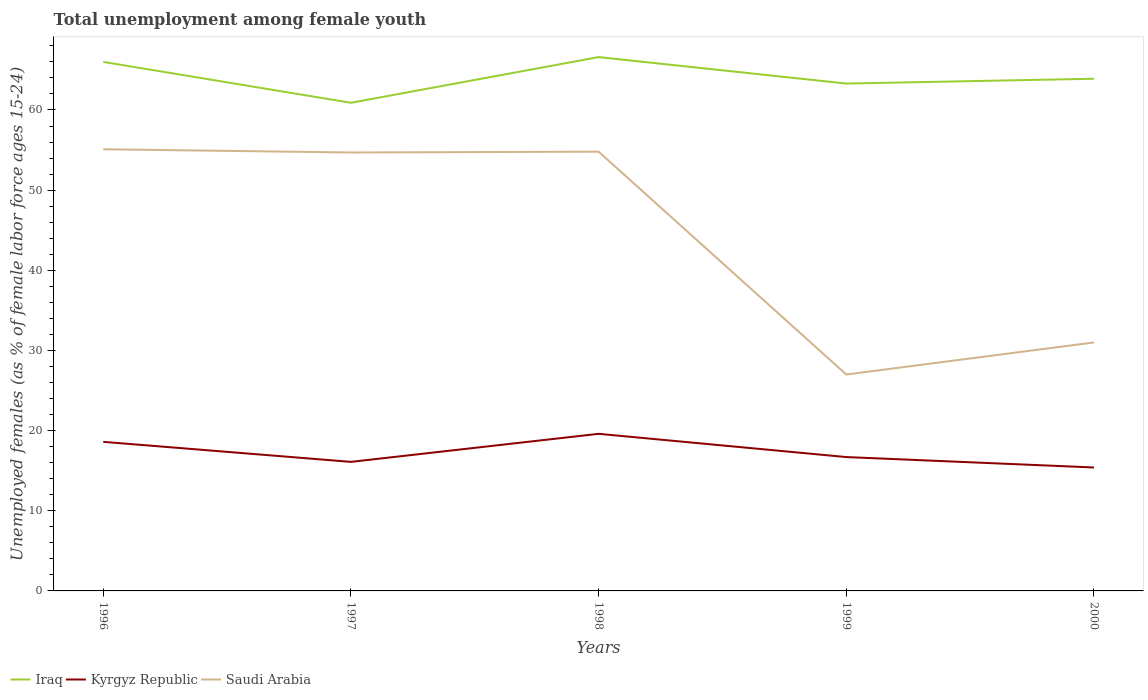How many different coloured lines are there?
Keep it short and to the point. 3. Is the number of lines equal to the number of legend labels?
Keep it short and to the point. Yes. Across all years, what is the maximum percentage of unemployed females in in Kyrgyz Republic?
Your answer should be very brief. 15.4. What is the total percentage of unemployed females in in Kyrgyz Republic in the graph?
Offer a very short reply. -1. What is the difference between the highest and the second highest percentage of unemployed females in in Kyrgyz Republic?
Ensure brevity in your answer.  4.2. What is the difference between the highest and the lowest percentage of unemployed females in in Kyrgyz Republic?
Make the answer very short. 2. Does the graph contain any zero values?
Give a very brief answer. No. Does the graph contain grids?
Make the answer very short. No. Where does the legend appear in the graph?
Offer a terse response. Bottom left. How are the legend labels stacked?
Offer a terse response. Horizontal. What is the title of the graph?
Your answer should be very brief. Total unemployment among female youth. Does "High income: nonOECD" appear as one of the legend labels in the graph?
Make the answer very short. No. What is the label or title of the Y-axis?
Provide a short and direct response. Unemployed females (as % of female labor force ages 15-24). What is the Unemployed females (as % of female labor force ages 15-24) in Kyrgyz Republic in 1996?
Keep it short and to the point. 18.6. What is the Unemployed females (as % of female labor force ages 15-24) of Saudi Arabia in 1996?
Offer a very short reply. 55.1. What is the Unemployed females (as % of female labor force ages 15-24) in Iraq in 1997?
Offer a terse response. 60.9. What is the Unemployed females (as % of female labor force ages 15-24) of Kyrgyz Republic in 1997?
Your answer should be compact. 16.1. What is the Unemployed females (as % of female labor force ages 15-24) in Saudi Arabia in 1997?
Keep it short and to the point. 54.7. What is the Unemployed females (as % of female labor force ages 15-24) in Iraq in 1998?
Your answer should be compact. 66.6. What is the Unemployed females (as % of female labor force ages 15-24) of Kyrgyz Republic in 1998?
Make the answer very short. 19.6. What is the Unemployed females (as % of female labor force ages 15-24) in Saudi Arabia in 1998?
Your answer should be compact. 54.8. What is the Unemployed females (as % of female labor force ages 15-24) of Iraq in 1999?
Offer a terse response. 63.3. What is the Unemployed females (as % of female labor force ages 15-24) of Kyrgyz Republic in 1999?
Provide a short and direct response. 16.7. What is the Unemployed females (as % of female labor force ages 15-24) of Iraq in 2000?
Your answer should be compact. 63.9. What is the Unemployed females (as % of female labor force ages 15-24) in Kyrgyz Republic in 2000?
Offer a terse response. 15.4. What is the Unemployed females (as % of female labor force ages 15-24) in Saudi Arabia in 2000?
Ensure brevity in your answer.  31. Across all years, what is the maximum Unemployed females (as % of female labor force ages 15-24) of Iraq?
Give a very brief answer. 66.6. Across all years, what is the maximum Unemployed females (as % of female labor force ages 15-24) in Kyrgyz Republic?
Offer a very short reply. 19.6. Across all years, what is the maximum Unemployed females (as % of female labor force ages 15-24) in Saudi Arabia?
Make the answer very short. 55.1. Across all years, what is the minimum Unemployed females (as % of female labor force ages 15-24) in Iraq?
Ensure brevity in your answer.  60.9. Across all years, what is the minimum Unemployed females (as % of female labor force ages 15-24) of Kyrgyz Republic?
Provide a short and direct response. 15.4. What is the total Unemployed females (as % of female labor force ages 15-24) of Iraq in the graph?
Your response must be concise. 320.7. What is the total Unemployed females (as % of female labor force ages 15-24) of Kyrgyz Republic in the graph?
Make the answer very short. 86.4. What is the total Unemployed females (as % of female labor force ages 15-24) in Saudi Arabia in the graph?
Offer a terse response. 222.6. What is the difference between the Unemployed females (as % of female labor force ages 15-24) of Iraq in 1996 and that in 1997?
Ensure brevity in your answer.  5.1. What is the difference between the Unemployed females (as % of female labor force ages 15-24) of Kyrgyz Republic in 1996 and that in 1997?
Give a very brief answer. 2.5. What is the difference between the Unemployed females (as % of female labor force ages 15-24) in Iraq in 1996 and that in 1998?
Provide a short and direct response. -0.6. What is the difference between the Unemployed females (as % of female labor force ages 15-24) in Iraq in 1996 and that in 1999?
Your answer should be compact. 2.7. What is the difference between the Unemployed females (as % of female labor force ages 15-24) in Kyrgyz Republic in 1996 and that in 1999?
Provide a short and direct response. 1.9. What is the difference between the Unemployed females (as % of female labor force ages 15-24) of Saudi Arabia in 1996 and that in 1999?
Give a very brief answer. 28.1. What is the difference between the Unemployed females (as % of female labor force ages 15-24) in Iraq in 1996 and that in 2000?
Keep it short and to the point. 2.1. What is the difference between the Unemployed females (as % of female labor force ages 15-24) of Saudi Arabia in 1996 and that in 2000?
Your answer should be very brief. 24.1. What is the difference between the Unemployed females (as % of female labor force ages 15-24) of Iraq in 1997 and that in 1998?
Your answer should be compact. -5.7. What is the difference between the Unemployed females (as % of female labor force ages 15-24) of Kyrgyz Republic in 1997 and that in 1998?
Offer a very short reply. -3.5. What is the difference between the Unemployed females (as % of female labor force ages 15-24) of Saudi Arabia in 1997 and that in 1998?
Provide a short and direct response. -0.1. What is the difference between the Unemployed females (as % of female labor force ages 15-24) in Saudi Arabia in 1997 and that in 1999?
Your response must be concise. 27.7. What is the difference between the Unemployed females (as % of female labor force ages 15-24) of Kyrgyz Republic in 1997 and that in 2000?
Ensure brevity in your answer.  0.7. What is the difference between the Unemployed females (as % of female labor force ages 15-24) of Saudi Arabia in 1997 and that in 2000?
Give a very brief answer. 23.7. What is the difference between the Unemployed females (as % of female labor force ages 15-24) in Saudi Arabia in 1998 and that in 1999?
Offer a terse response. 27.8. What is the difference between the Unemployed females (as % of female labor force ages 15-24) of Saudi Arabia in 1998 and that in 2000?
Make the answer very short. 23.8. What is the difference between the Unemployed females (as % of female labor force ages 15-24) of Iraq in 1999 and that in 2000?
Offer a very short reply. -0.6. What is the difference between the Unemployed females (as % of female labor force ages 15-24) in Saudi Arabia in 1999 and that in 2000?
Provide a succinct answer. -4. What is the difference between the Unemployed females (as % of female labor force ages 15-24) in Iraq in 1996 and the Unemployed females (as % of female labor force ages 15-24) in Kyrgyz Republic in 1997?
Provide a succinct answer. 49.9. What is the difference between the Unemployed females (as % of female labor force ages 15-24) in Kyrgyz Republic in 1996 and the Unemployed females (as % of female labor force ages 15-24) in Saudi Arabia in 1997?
Offer a very short reply. -36.1. What is the difference between the Unemployed females (as % of female labor force ages 15-24) of Iraq in 1996 and the Unemployed females (as % of female labor force ages 15-24) of Kyrgyz Republic in 1998?
Your answer should be very brief. 46.4. What is the difference between the Unemployed females (as % of female labor force ages 15-24) of Iraq in 1996 and the Unemployed females (as % of female labor force ages 15-24) of Saudi Arabia in 1998?
Ensure brevity in your answer.  11.2. What is the difference between the Unemployed females (as % of female labor force ages 15-24) in Kyrgyz Republic in 1996 and the Unemployed females (as % of female labor force ages 15-24) in Saudi Arabia in 1998?
Your response must be concise. -36.2. What is the difference between the Unemployed females (as % of female labor force ages 15-24) in Iraq in 1996 and the Unemployed females (as % of female labor force ages 15-24) in Kyrgyz Republic in 1999?
Give a very brief answer. 49.3. What is the difference between the Unemployed females (as % of female labor force ages 15-24) of Kyrgyz Republic in 1996 and the Unemployed females (as % of female labor force ages 15-24) of Saudi Arabia in 1999?
Ensure brevity in your answer.  -8.4. What is the difference between the Unemployed females (as % of female labor force ages 15-24) in Iraq in 1996 and the Unemployed females (as % of female labor force ages 15-24) in Kyrgyz Republic in 2000?
Make the answer very short. 50.6. What is the difference between the Unemployed females (as % of female labor force ages 15-24) in Kyrgyz Republic in 1996 and the Unemployed females (as % of female labor force ages 15-24) in Saudi Arabia in 2000?
Provide a succinct answer. -12.4. What is the difference between the Unemployed females (as % of female labor force ages 15-24) of Iraq in 1997 and the Unemployed females (as % of female labor force ages 15-24) of Kyrgyz Republic in 1998?
Provide a succinct answer. 41.3. What is the difference between the Unemployed females (as % of female labor force ages 15-24) in Iraq in 1997 and the Unemployed females (as % of female labor force ages 15-24) in Saudi Arabia in 1998?
Your response must be concise. 6.1. What is the difference between the Unemployed females (as % of female labor force ages 15-24) of Kyrgyz Republic in 1997 and the Unemployed females (as % of female labor force ages 15-24) of Saudi Arabia in 1998?
Offer a terse response. -38.7. What is the difference between the Unemployed females (as % of female labor force ages 15-24) in Iraq in 1997 and the Unemployed females (as % of female labor force ages 15-24) in Kyrgyz Republic in 1999?
Give a very brief answer. 44.2. What is the difference between the Unemployed females (as % of female labor force ages 15-24) in Iraq in 1997 and the Unemployed females (as % of female labor force ages 15-24) in Saudi Arabia in 1999?
Make the answer very short. 33.9. What is the difference between the Unemployed females (as % of female labor force ages 15-24) of Kyrgyz Republic in 1997 and the Unemployed females (as % of female labor force ages 15-24) of Saudi Arabia in 1999?
Your answer should be compact. -10.9. What is the difference between the Unemployed females (as % of female labor force ages 15-24) of Iraq in 1997 and the Unemployed females (as % of female labor force ages 15-24) of Kyrgyz Republic in 2000?
Offer a very short reply. 45.5. What is the difference between the Unemployed females (as % of female labor force ages 15-24) of Iraq in 1997 and the Unemployed females (as % of female labor force ages 15-24) of Saudi Arabia in 2000?
Your answer should be very brief. 29.9. What is the difference between the Unemployed females (as % of female labor force ages 15-24) in Kyrgyz Republic in 1997 and the Unemployed females (as % of female labor force ages 15-24) in Saudi Arabia in 2000?
Your response must be concise. -14.9. What is the difference between the Unemployed females (as % of female labor force ages 15-24) of Iraq in 1998 and the Unemployed females (as % of female labor force ages 15-24) of Kyrgyz Republic in 1999?
Provide a succinct answer. 49.9. What is the difference between the Unemployed females (as % of female labor force ages 15-24) in Iraq in 1998 and the Unemployed females (as % of female labor force ages 15-24) in Saudi Arabia in 1999?
Give a very brief answer. 39.6. What is the difference between the Unemployed females (as % of female labor force ages 15-24) of Iraq in 1998 and the Unemployed females (as % of female labor force ages 15-24) of Kyrgyz Republic in 2000?
Provide a short and direct response. 51.2. What is the difference between the Unemployed females (as % of female labor force ages 15-24) of Iraq in 1998 and the Unemployed females (as % of female labor force ages 15-24) of Saudi Arabia in 2000?
Offer a very short reply. 35.6. What is the difference between the Unemployed females (as % of female labor force ages 15-24) in Iraq in 1999 and the Unemployed females (as % of female labor force ages 15-24) in Kyrgyz Republic in 2000?
Provide a succinct answer. 47.9. What is the difference between the Unemployed females (as % of female labor force ages 15-24) of Iraq in 1999 and the Unemployed females (as % of female labor force ages 15-24) of Saudi Arabia in 2000?
Your answer should be very brief. 32.3. What is the difference between the Unemployed females (as % of female labor force ages 15-24) of Kyrgyz Republic in 1999 and the Unemployed females (as % of female labor force ages 15-24) of Saudi Arabia in 2000?
Keep it short and to the point. -14.3. What is the average Unemployed females (as % of female labor force ages 15-24) in Iraq per year?
Provide a succinct answer. 64.14. What is the average Unemployed females (as % of female labor force ages 15-24) of Kyrgyz Republic per year?
Ensure brevity in your answer.  17.28. What is the average Unemployed females (as % of female labor force ages 15-24) of Saudi Arabia per year?
Make the answer very short. 44.52. In the year 1996, what is the difference between the Unemployed females (as % of female labor force ages 15-24) in Iraq and Unemployed females (as % of female labor force ages 15-24) in Kyrgyz Republic?
Ensure brevity in your answer.  47.4. In the year 1996, what is the difference between the Unemployed females (as % of female labor force ages 15-24) of Iraq and Unemployed females (as % of female labor force ages 15-24) of Saudi Arabia?
Provide a succinct answer. 10.9. In the year 1996, what is the difference between the Unemployed females (as % of female labor force ages 15-24) of Kyrgyz Republic and Unemployed females (as % of female labor force ages 15-24) of Saudi Arabia?
Your answer should be compact. -36.5. In the year 1997, what is the difference between the Unemployed females (as % of female labor force ages 15-24) in Iraq and Unemployed females (as % of female labor force ages 15-24) in Kyrgyz Republic?
Offer a terse response. 44.8. In the year 1997, what is the difference between the Unemployed females (as % of female labor force ages 15-24) in Iraq and Unemployed females (as % of female labor force ages 15-24) in Saudi Arabia?
Your answer should be very brief. 6.2. In the year 1997, what is the difference between the Unemployed females (as % of female labor force ages 15-24) of Kyrgyz Republic and Unemployed females (as % of female labor force ages 15-24) of Saudi Arabia?
Your answer should be compact. -38.6. In the year 1998, what is the difference between the Unemployed females (as % of female labor force ages 15-24) of Kyrgyz Republic and Unemployed females (as % of female labor force ages 15-24) of Saudi Arabia?
Provide a succinct answer. -35.2. In the year 1999, what is the difference between the Unemployed females (as % of female labor force ages 15-24) of Iraq and Unemployed females (as % of female labor force ages 15-24) of Kyrgyz Republic?
Provide a short and direct response. 46.6. In the year 1999, what is the difference between the Unemployed females (as % of female labor force ages 15-24) of Iraq and Unemployed females (as % of female labor force ages 15-24) of Saudi Arabia?
Provide a short and direct response. 36.3. In the year 2000, what is the difference between the Unemployed females (as % of female labor force ages 15-24) of Iraq and Unemployed females (as % of female labor force ages 15-24) of Kyrgyz Republic?
Keep it short and to the point. 48.5. In the year 2000, what is the difference between the Unemployed females (as % of female labor force ages 15-24) of Iraq and Unemployed females (as % of female labor force ages 15-24) of Saudi Arabia?
Provide a short and direct response. 32.9. In the year 2000, what is the difference between the Unemployed females (as % of female labor force ages 15-24) in Kyrgyz Republic and Unemployed females (as % of female labor force ages 15-24) in Saudi Arabia?
Offer a very short reply. -15.6. What is the ratio of the Unemployed females (as % of female labor force ages 15-24) in Iraq in 1996 to that in 1997?
Offer a terse response. 1.08. What is the ratio of the Unemployed females (as % of female labor force ages 15-24) of Kyrgyz Republic in 1996 to that in 1997?
Give a very brief answer. 1.16. What is the ratio of the Unemployed females (as % of female labor force ages 15-24) of Saudi Arabia in 1996 to that in 1997?
Your answer should be compact. 1.01. What is the ratio of the Unemployed females (as % of female labor force ages 15-24) in Kyrgyz Republic in 1996 to that in 1998?
Give a very brief answer. 0.95. What is the ratio of the Unemployed females (as % of female labor force ages 15-24) of Saudi Arabia in 1996 to that in 1998?
Give a very brief answer. 1.01. What is the ratio of the Unemployed females (as % of female labor force ages 15-24) of Iraq in 1996 to that in 1999?
Make the answer very short. 1.04. What is the ratio of the Unemployed females (as % of female labor force ages 15-24) in Kyrgyz Republic in 1996 to that in 1999?
Your answer should be compact. 1.11. What is the ratio of the Unemployed females (as % of female labor force ages 15-24) in Saudi Arabia in 1996 to that in 1999?
Your answer should be compact. 2.04. What is the ratio of the Unemployed females (as % of female labor force ages 15-24) of Iraq in 1996 to that in 2000?
Give a very brief answer. 1.03. What is the ratio of the Unemployed females (as % of female labor force ages 15-24) of Kyrgyz Republic in 1996 to that in 2000?
Ensure brevity in your answer.  1.21. What is the ratio of the Unemployed females (as % of female labor force ages 15-24) of Saudi Arabia in 1996 to that in 2000?
Ensure brevity in your answer.  1.78. What is the ratio of the Unemployed females (as % of female labor force ages 15-24) of Iraq in 1997 to that in 1998?
Ensure brevity in your answer.  0.91. What is the ratio of the Unemployed females (as % of female labor force ages 15-24) in Kyrgyz Republic in 1997 to that in 1998?
Your answer should be compact. 0.82. What is the ratio of the Unemployed females (as % of female labor force ages 15-24) of Saudi Arabia in 1997 to that in 1998?
Keep it short and to the point. 1. What is the ratio of the Unemployed females (as % of female labor force ages 15-24) in Iraq in 1997 to that in 1999?
Provide a short and direct response. 0.96. What is the ratio of the Unemployed females (as % of female labor force ages 15-24) in Kyrgyz Republic in 1997 to that in 1999?
Make the answer very short. 0.96. What is the ratio of the Unemployed females (as % of female labor force ages 15-24) of Saudi Arabia in 1997 to that in 1999?
Your answer should be compact. 2.03. What is the ratio of the Unemployed females (as % of female labor force ages 15-24) in Iraq in 1997 to that in 2000?
Provide a succinct answer. 0.95. What is the ratio of the Unemployed females (as % of female labor force ages 15-24) of Kyrgyz Republic in 1997 to that in 2000?
Make the answer very short. 1.05. What is the ratio of the Unemployed females (as % of female labor force ages 15-24) of Saudi Arabia in 1997 to that in 2000?
Your answer should be very brief. 1.76. What is the ratio of the Unemployed females (as % of female labor force ages 15-24) in Iraq in 1998 to that in 1999?
Provide a succinct answer. 1.05. What is the ratio of the Unemployed females (as % of female labor force ages 15-24) in Kyrgyz Republic in 1998 to that in 1999?
Offer a terse response. 1.17. What is the ratio of the Unemployed females (as % of female labor force ages 15-24) of Saudi Arabia in 1998 to that in 1999?
Offer a terse response. 2.03. What is the ratio of the Unemployed females (as % of female labor force ages 15-24) in Iraq in 1998 to that in 2000?
Your response must be concise. 1.04. What is the ratio of the Unemployed females (as % of female labor force ages 15-24) in Kyrgyz Republic in 1998 to that in 2000?
Ensure brevity in your answer.  1.27. What is the ratio of the Unemployed females (as % of female labor force ages 15-24) in Saudi Arabia in 1998 to that in 2000?
Ensure brevity in your answer.  1.77. What is the ratio of the Unemployed females (as % of female labor force ages 15-24) of Iraq in 1999 to that in 2000?
Provide a short and direct response. 0.99. What is the ratio of the Unemployed females (as % of female labor force ages 15-24) in Kyrgyz Republic in 1999 to that in 2000?
Give a very brief answer. 1.08. What is the ratio of the Unemployed females (as % of female labor force ages 15-24) in Saudi Arabia in 1999 to that in 2000?
Provide a succinct answer. 0.87. What is the difference between the highest and the second highest Unemployed females (as % of female labor force ages 15-24) in Iraq?
Offer a very short reply. 0.6. What is the difference between the highest and the second highest Unemployed females (as % of female labor force ages 15-24) in Saudi Arabia?
Your answer should be very brief. 0.3. What is the difference between the highest and the lowest Unemployed females (as % of female labor force ages 15-24) in Iraq?
Provide a short and direct response. 5.7. What is the difference between the highest and the lowest Unemployed females (as % of female labor force ages 15-24) in Saudi Arabia?
Make the answer very short. 28.1. 